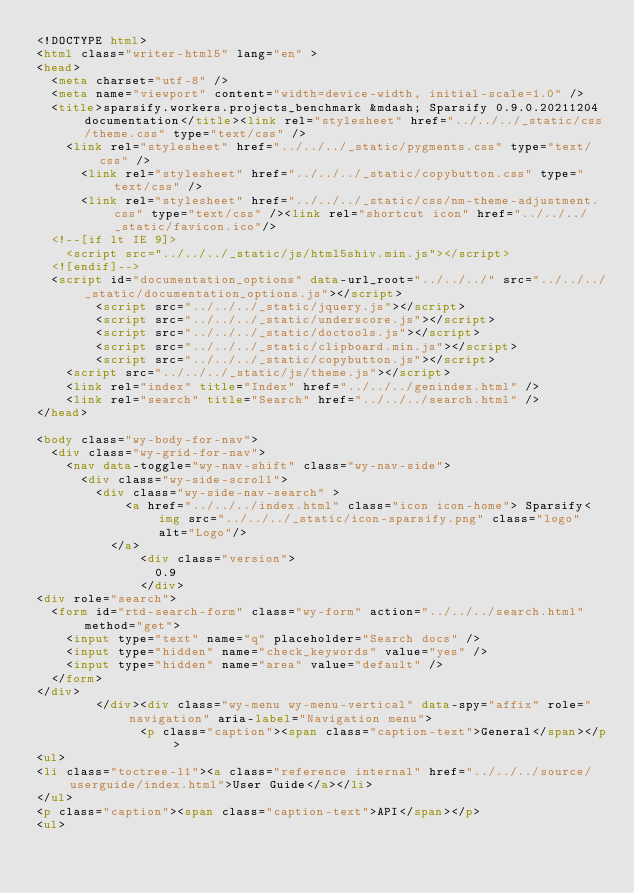<code> <loc_0><loc_0><loc_500><loc_500><_HTML_><!DOCTYPE html>
<html class="writer-html5" lang="en" >
<head>
  <meta charset="utf-8" />
  <meta name="viewport" content="width=device-width, initial-scale=1.0" />
  <title>sparsify.workers.projects_benchmark &mdash; Sparsify 0.9.0.20211204 documentation</title><link rel="stylesheet" href="../../../_static/css/theme.css" type="text/css" />
    <link rel="stylesheet" href="../../../_static/pygments.css" type="text/css" />
      <link rel="stylesheet" href="../../../_static/copybutton.css" type="text/css" />
      <link rel="stylesheet" href="../../../_static/css/nm-theme-adjustment.css" type="text/css" /><link rel="shortcut icon" href="../../../_static/favicon.ico"/>
  <!--[if lt IE 9]>
    <script src="../../../_static/js/html5shiv.min.js"></script>
  <![endif]-->
  <script id="documentation_options" data-url_root="../../../" src="../../../_static/documentation_options.js"></script>
        <script src="../../../_static/jquery.js"></script>
        <script src="../../../_static/underscore.js"></script>
        <script src="../../../_static/doctools.js"></script>
        <script src="../../../_static/clipboard.min.js"></script>
        <script src="../../../_static/copybutton.js"></script>
    <script src="../../../_static/js/theme.js"></script>
    <link rel="index" title="Index" href="../../../genindex.html" />
    <link rel="search" title="Search" href="../../../search.html" /> 
</head>

<body class="wy-body-for-nav"> 
  <div class="wy-grid-for-nav">
    <nav data-toggle="wy-nav-shift" class="wy-nav-side">
      <div class="wy-side-scroll">
        <div class="wy-side-nav-search" >
            <a href="../../../index.html" class="icon icon-home"> Sparsify<img src="../../../_static/icon-sparsify.png" class="logo" alt="Logo"/>
          </a>
              <div class="version">
                0.9
              </div>
<div role="search">
  <form id="rtd-search-form" class="wy-form" action="../../../search.html" method="get">
    <input type="text" name="q" placeholder="Search docs" />
    <input type="hidden" name="check_keywords" value="yes" />
    <input type="hidden" name="area" value="default" />
  </form>
</div>
        </div><div class="wy-menu wy-menu-vertical" data-spy="affix" role="navigation" aria-label="Navigation menu">
              <p class="caption"><span class="caption-text">General</span></p>
<ul>
<li class="toctree-l1"><a class="reference internal" href="../../../source/userguide/index.html">User Guide</a></li>
</ul>
<p class="caption"><span class="caption-text">API</span></p>
<ul></code> 